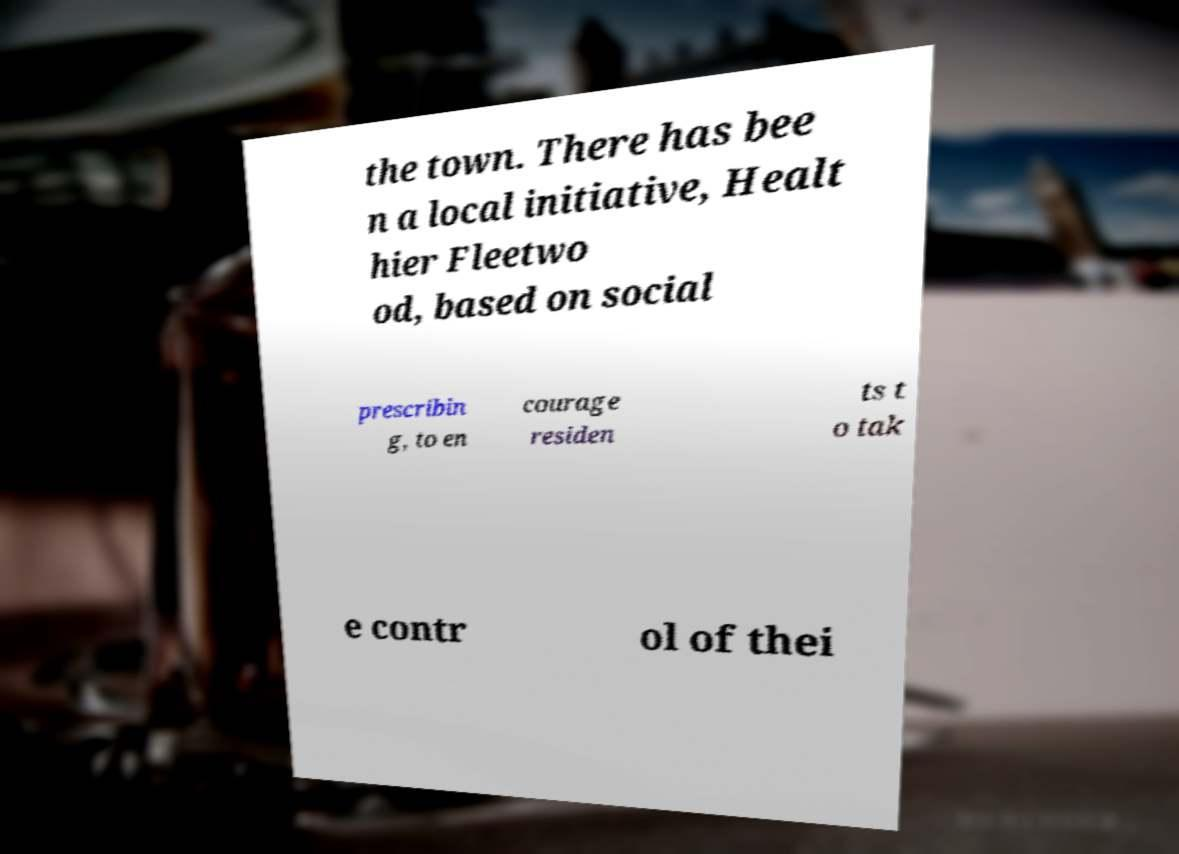Can you accurately transcribe the text from the provided image for me? the town. There has bee n a local initiative, Healt hier Fleetwo od, based on social prescribin g, to en courage residen ts t o tak e contr ol of thei 